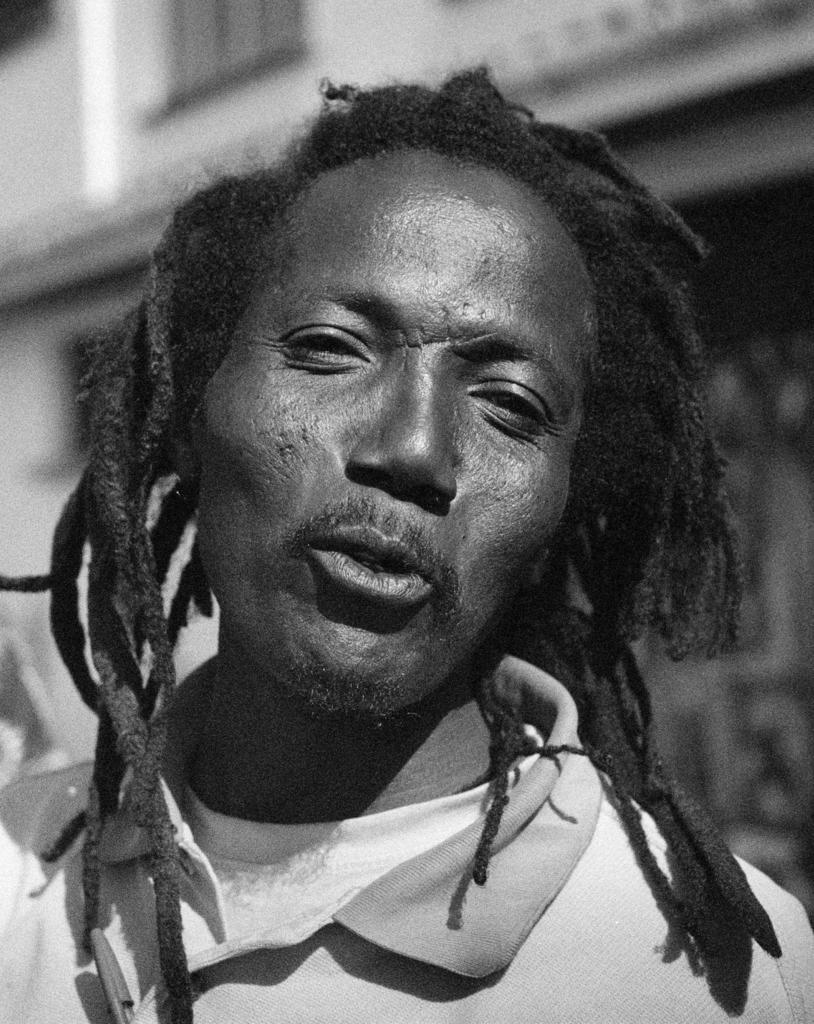Who is present in the image? There is a man in the image. What is the man wearing? The man is wearing a T-shirt. What can be seen in the background of the image? There is a building in the background of the image. What type of wren can be seen perched on the man's shoulder in the image? There is no wren present in the image; only the man and a building in the background are visible. 